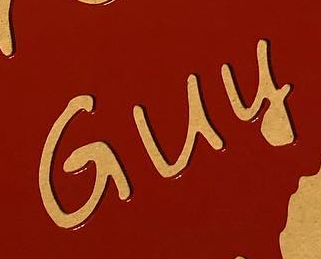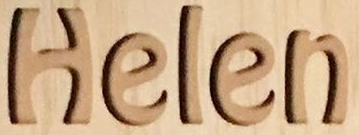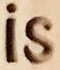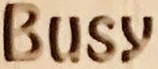What words are shown in these images in order, separated by a semicolon? Guy; Helen; is; Busy 